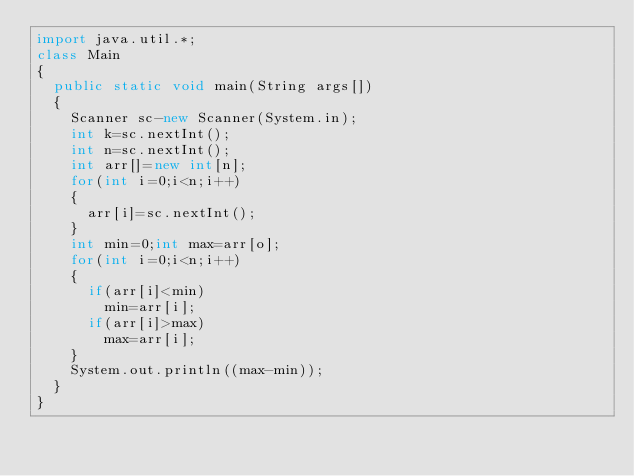<code> <loc_0><loc_0><loc_500><loc_500><_Java_>import java.util.*;
class Main
{
  public static void main(String args[])
  {
    Scanner sc-new Scanner(System.in);
    int k=sc.nextInt();
    int n=sc.nextInt();
    int arr[]=new int[n];
    for(int i=0;i<n;i++)
    {
      arr[i]=sc.nextInt();
    }
    int min=0;int max=arr[o];
    for(int i=0;i<n;i++)
    {
      if(arr[i]<min)
        min=arr[i];
      if(arr[i]>max)
        max=arr[i];
    }
    System.out.println((max-min));
  }
}
</code> 